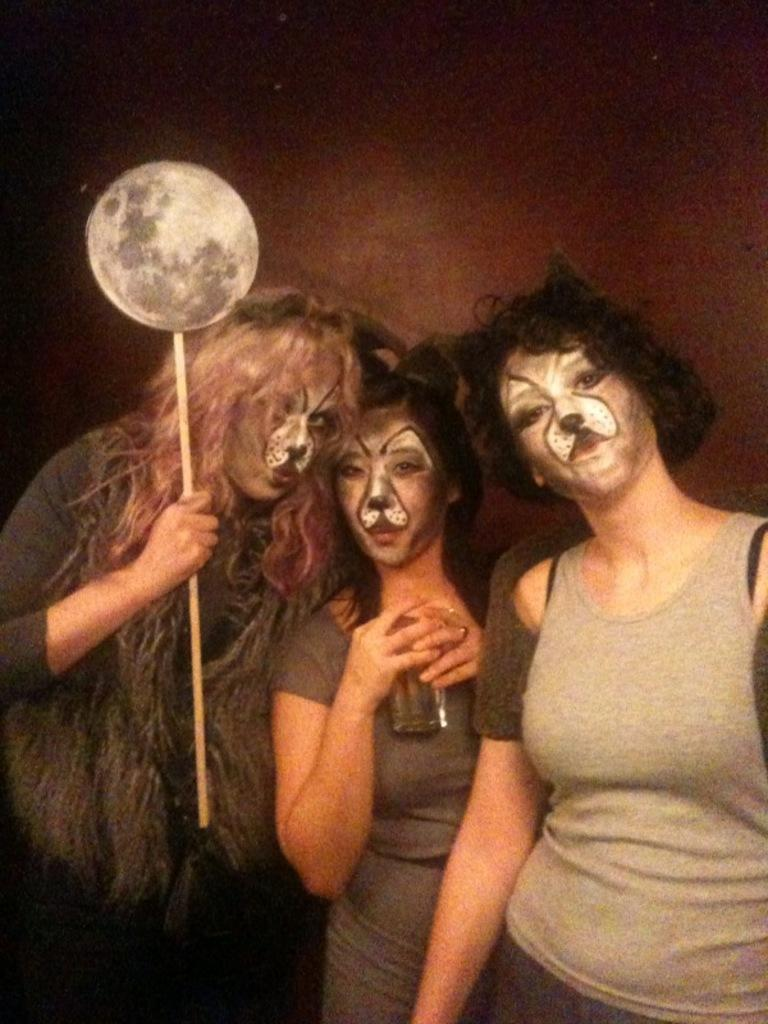Where was the image taken? The image was taken indoors. What can be seen in the background of the image? There is a wall in the background of the image. How many women are in the image? There are three women in the image. What are the women standing on? The women are standing on the floor. What are the women holding in their hands? Each woman is holding a glass and a stick. What type of cloud can be seen in the image? There are no clouds present in the image, as it was taken indoors. 